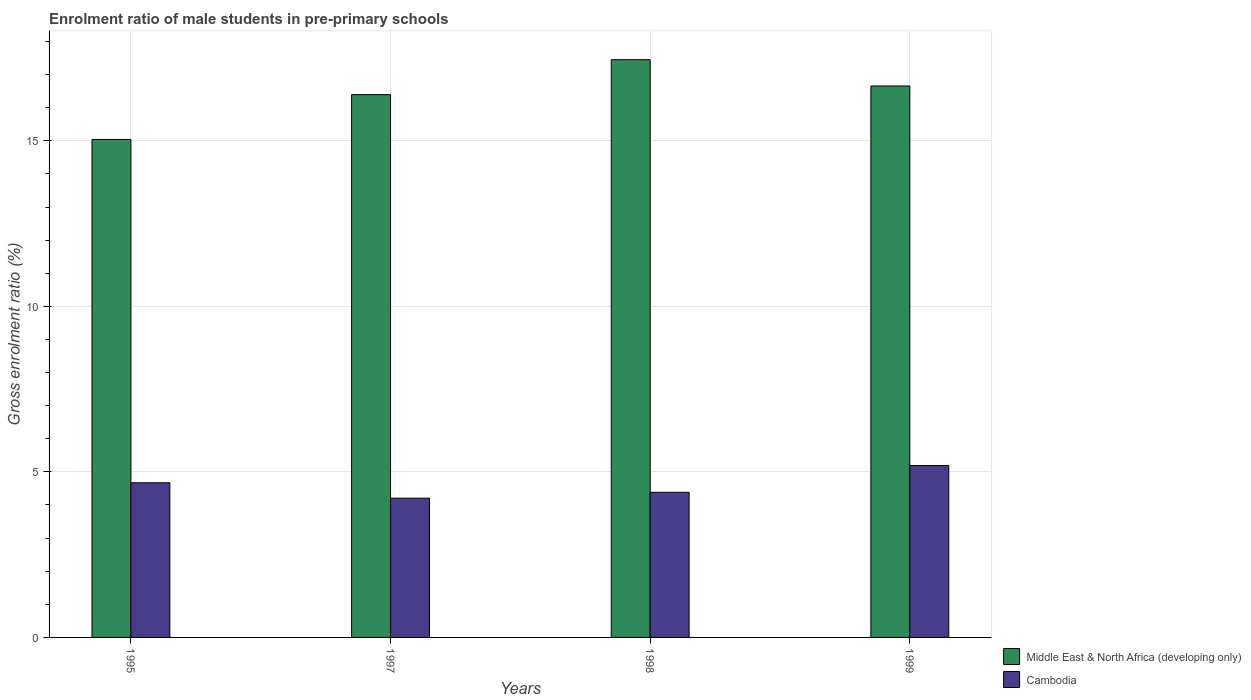How many different coloured bars are there?
Offer a terse response. 2. How many groups of bars are there?
Provide a short and direct response. 4. Are the number of bars on each tick of the X-axis equal?
Ensure brevity in your answer.  Yes. How many bars are there on the 3rd tick from the left?
Keep it short and to the point. 2. How many bars are there on the 4th tick from the right?
Ensure brevity in your answer.  2. What is the label of the 2nd group of bars from the left?
Provide a succinct answer. 1997. What is the enrolment ratio of male students in pre-primary schools in Middle East & North Africa (developing only) in 1999?
Your answer should be compact. 16.66. Across all years, what is the maximum enrolment ratio of male students in pre-primary schools in Middle East & North Africa (developing only)?
Give a very brief answer. 17.45. Across all years, what is the minimum enrolment ratio of male students in pre-primary schools in Cambodia?
Your answer should be very brief. 4.21. In which year was the enrolment ratio of male students in pre-primary schools in Middle East & North Africa (developing only) maximum?
Your answer should be compact. 1998. What is the total enrolment ratio of male students in pre-primary schools in Cambodia in the graph?
Make the answer very short. 18.45. What is the difference between the enrolment ratio of male students in pre-primary schools in Cambodia in 1998 and that in 1999?
Provide a short and direct response. -0.81. What is the difference between the enrolment ratio of male students in pre-primary schools in Middle East & North Africa (developing only) in 1997 and the enrolment ratio of male students in pre-primary schools in Cambodia in 1998?
Keep it short and to the point. 12.01. What is the average enrolment ratio of male students in pre-primary schools in Middle East & North Africa (developing only) per year?
Make the answer very short. 16.38. In the year 1999, what is the difference between the enrolment ratio of male students in pre-primary schools in Cambodia and enrolment ratio of male students in pre-primary schools in Middle East & North Africa (developing only)?
Provide a short and direct response. -11.46. What is the ratio of the enrolment ratio of male students in pre-primary schools in Cambodia in 1995 to that in 1997?
Your response must be concise. 1.11. What is the difference between the highest and the second highest enrolment ratio of male students in pre-primary schools in Cambodia?
Give a very brief answer. 0.52. What is the difference between the highest and the lowest enrolment ratio of male students in pre-primary schools in Middle East & North Africa (developing only)?
Offer a very short reply. 2.41. What does the 1st bar from the left in 1998 represents?
Keep it short and to the point. Middle East & North Africa (developing only). What does the 2nd bar from the right in 1997 represents?
Provide a succinct answer. Middle East & North Africa (developing only). Are all the bars in the graph horizontal?
Ensure brevity in your answer.  No. Are the values on the major ticks of Y-axis written in scientific E-notation?
Offer a terse response. No. Does the graph contain any zero values?
Your answer should be very brief. No. Where does the legend appear in the graph?
Offer a terse response. Bottom right. How are the legend labels stacked?
Your answer should be very brief. Vertical. What is the title of the graph?
Your response must be concise. Enrolment ratio of male students in pre-primary schools. Does "Venezuela" appear as one of the legend labels in the graph?
Your response must be concise. No. What is the Gross enrolment ratio (%) in Middle East & North Africa (developing only) in 1995?
Keep it short and to the point. 15.04. What is the Gross enrolment ratio (%) in Cambodia in 1995?
Give a very brief answer. 4.67. What is the Gross enrolment ratio (%) in Middle East & North Africa (developing only) in 1997?
Provide a succinct answer. 16.39. What is the Gross enrolment ratio (%) in Cambodia in 1997?
Provide a short and direct response. 4.21. What is the Gross enrolment ratio (%) in Middle East & North Africa (developing only) in 1998?
Give a very brief answer. 17.45. What is the Gross enrolment ratio (%) in Cambodia in 1998?
Provide a short and direct response. 4.38. What is the Gross enrolment ratio (%) of Middle East & North Africa (developing only) in 1999?
Offer a very short reply. 16.66. What is the Gross enrolment ratio (%) in Cambodia in 1999?
Keep it short and to the point. 5.19. Across all years, what is the maximum Gross enrolment ratio (%) of Middle East & North Africa (developing only)?
Offer a terse response. 17.45. Across all years, what is the maximum Gross enrolment ratio (%) in Cambodia?
Your response must be concise. 5.19. Across all years, what is the minimum Gross enrolment ratio (%) in Middle East & North Africa (developing only)?
Give a very brief answer. 15.04. Across all years, what is the minimum Gross enrolment ratio (%) of Cambodia?
Give a very brief answer. 4.21. What is the total Gross enrolment ratio (%) of Middle East & North Africa (developing only) in the graph?
Your response must be concise. 65.54. What is the total Gross enrolment ratio (%) of Cambodia in the graph?
Provide a short and direct response. 18.45. What is the difference between the Gross enrolment ratio (%) of Middle East & North Africa (developing only) in 1995 and that in 1997?
Keep it short and to the point. -1.35. What is the difference between the Gross enrolment ratio (%) of Cambodia in 1995 and that in 1997?
Offer a very short reply. 0.46. What is the difference between the Gross enrolment ratio (%) in Middle East & North Africa (developing only) in 1995 and that in 1998?
Keep it short and to the point. -2.41. What is the difference between the Gross enrolment ratio (%) in Cambodia in 1995 and that in 1998?
Your answer should be compact. 0.29. What is the difference between the Gross enrolment ratio (%) in Middle East & North Africa (developing only) in 1995 and that in 1999?
Keep it short and to the point. -1.62. What is the difference between the Gross enrolment ratio (%) of Cambodia in 1995 and that in 1999?
Offer a very short reply. -0.52. What is the difference between the Gross enrolment ratio (%) of Middle East & North Africa (developing only) in 1997 and that in 1998?
Offer a very short reply. -1.06. What is the difference between the Gross enrolment ratio (%) of Cambodia in 1997 and that in 1998?
Your response must be concise. -0.18. What is the difference between the Gross enrolment ratio (%) in Middle East & North Africa (developing only) in 1997 and that in 1999?
Ensure brevity in your answer.  -0.26. What is the difference between the Gross enrolment ratio (%) in Cambodia in 1997 and that in 1999?
Offer a very short reply. -0.98. What is the difference between the Gross enrolment ratio (%) of Middle East & North Africa (developing only) in 1998 and that in 1999?
Offer a terse response. 0.79. What is the difference between the Gross enrolment ratio (%) in Cambodia in 1998 and that in 1999?
Provide a succinct answer. -0.81. What is the difference between the Gross enrolment ratio (%) of Middle East & North Africa (developing only) in 1995 and the Gross enrolment ratio (%) of Cambodia in 1997?
Give a very brief answer. 10.83. What is the difference between the Gross enrolment ratio (%) in Middle East & North Africa (developing only) in 1995 and the Gross enrolment ratio (%) in Cambodia in 1998?
Give a very brief answer. 10.66. What is the difference between the Gross enrolment ratio (%) of Middle East & North Africa (developing only) in 1995 and the Gross enrolment ratio (%) of Cambodia in 1999?
Your answer should be compact. 9.85. What is the difference between the Gross enrolment ratio (%) in Middle East & North Africa (developing only) in 1997 and the Gross enrolment ratio (%) in Cambodia in 1998?
Your answer should be compact. 12.01. What is the difference between the Gross enrolment ratio (%) of Middle East & North Africa (developing only) in 1997 and the Gross enrolment ratio (%) of Cambodia in 1999?
Provide a succinct answer. 11.2. What is the difference between the Gross enrolment ratio (%) of Middle East & North Africa (developing only) in 1998 and the Gross enrolment ratio (%) of Cambodia in 1999?
Give a very brief answer. 12.26. What is the average Gross enrolment ratio (%) of Middle East & North Africa (developing only) per year?
Your answer should be very brief. 16.38. What is the average Gross enrolment ratio (%) in Cambodia per year?
Keep it short and to the point. 4.61. In the year 1995, what is the difference between the Gross enrolment ratio (%) in Middle East & North Africa (developing only) and Gross enrolment ratio (%) in Cambodia?
Offer a very short reply. 10.37. In the year 1997, what is the difference between the Gross enrolment ratio (%) in Middle East & North Africa (developing only) and Gross enrolment ratio (%) in Cambodia?
Make the answer very short. 12.19. In the year 1998, what is the difference between the Gross enrolment ratio (%) in Middle East & North Africa (developing only) and Gross enrolment ratio (%) in Cambodia?
Provide a short and direct response. 13.07. In the year 1999, what is the difference between the Gross enrolment ratio (%) of Middle East & North Africa (developing only) and Gross enrolment ratio (%) of Cambodia?
Give a very brief answer. 11.46. What is the ratio of the Gross enrolment ratio (%) in Middle East & North Africa (developing only) in 1995 to that in 1997?
Your response must be concise. 0.92. What is the ratio of the Gross enrolment ratio (%) of Cambodia in 1995 to that in 1997?
Offer a very short reply. 1.11. What is the ratio of the Gross enrolment ratio (%) in Middle East & North Africa (developing only) in 1995 to that in 1998?
Keep it short and to the point. 0.86. What is the ratio of the Gross enrolment ratio (%) of Cambodia in 1995 to that in 1998?
Your answer should be compact. 1.07. What is the ratio of the Gross enrolment ratio (%) of Middle East & North Africa (developing only) in 1995 to that in 1999?
Offer a terse response. 0.9. What is the ratio of the Gross enrolment ratio (%) of Cambodia in 1995 to that in 1999?
Ensure brevity in your answer.  0.9. What is the ratio of the Gross enrolment ratio (%) in Middle East & North Africa (developing only) in 1997 to that in 1998?
Make the answer very short. 0.94. What is the ratio of the Gross enrolment ratio (%) of Cambodia in 1997 to that in 1998?
Provide a short and direct response. 0.96. What is the ratio of the Gross enrolment ratio (%) of Middle East & North Africa (developing only) in 1997 to that in 1999?
Your response must be concise. 0.98. What is the ratio of the Gross enrolment ratio (%) of Cambodia in 1997 to that in 1999?
Provide a succinct answer. 0.81. What is the ratio of the Gross enrolment ratio (%) in Middle East & North Africa (developing only) in 1998 to that in 1999?
Offer a terse response. 1.05. What is the ratio of the Gross enrolment ratio (%) in Cambodia in 1998 to that in 1999?
Make the answer very short. 0.84. What is the difference between the highest and the second highest Gross enrolment ratio (%) in Middle East & North Africa (developing only)?
Your answer should be compact. 0.79. What is the difference between the highest and the second highest Gross enrolment ratio (%) in Cambodia?
Provide a short and direct response. 0.52. What is the difference between the highest and the lowest Gross enrolment ratio (%) of Middle East & North Africa (developing only)?
Keep it short and to the point. 2.41. What is the difference between the highest and the lowest Gross enrolment ratio (%) in Cambodia?
Your answer should be very brief. 0.98. 